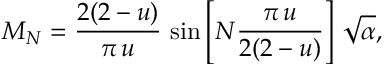Convert formula to latex. <formula><loc_0><loc_0><loc_500><loc_500>M _ { N } = \frac { 2 ( 2 - u ) } { \pi \, u } \, \sin \left [ N \frac { \pi \, u } { 2 ( 2 - u ) } \right ] \, \sqrt { \alpha } ,</formula> 